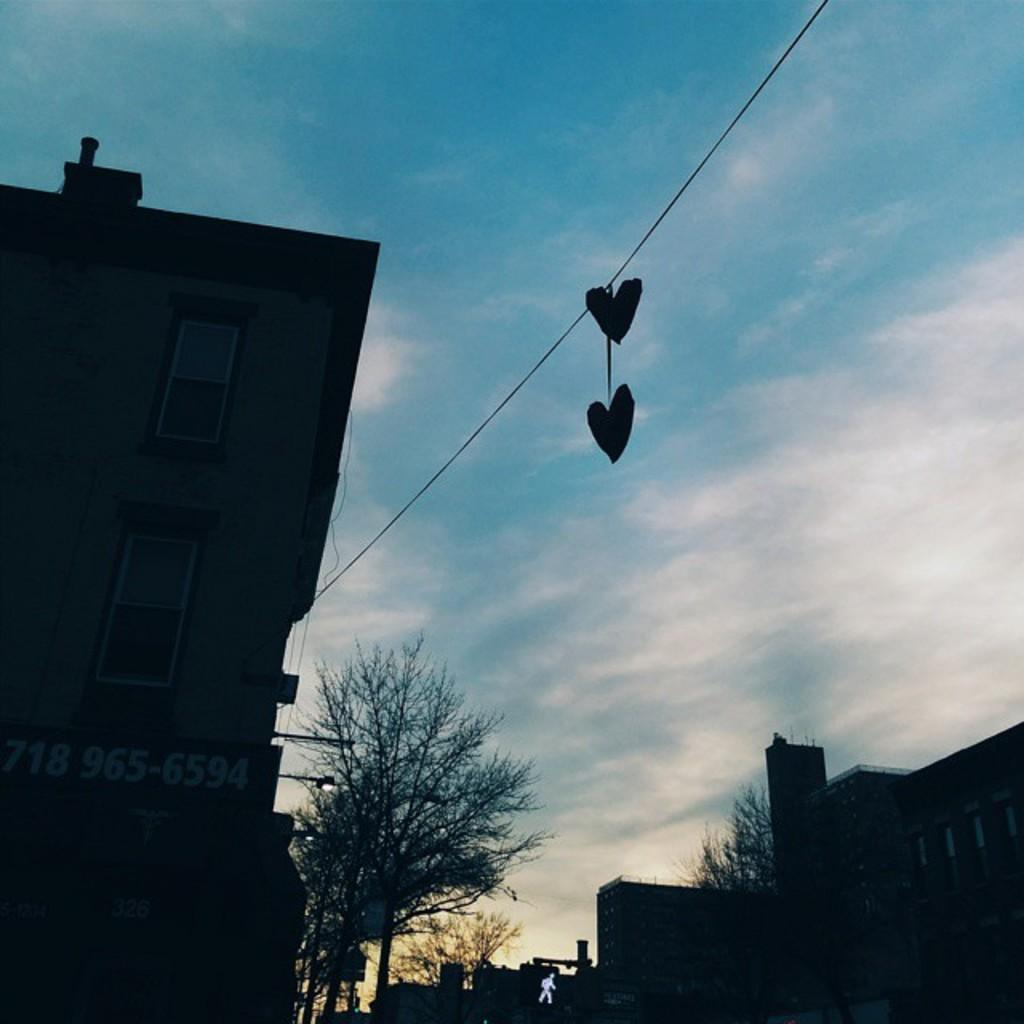What type of structures can be seen in the image? There are buildings in the image. What other natural elements are present in the image? There are trees in the image. Can you describe any man-made objects in the image? There is a board and a sign board in the image. Are there any visible electrical elements in the image? Yes, there are wires in the image. What is visible in the sky at the top of the image? Clouds are present in the sky at the top of the image. Where is the locket hanging in the image? There is no locket present in the image. What type of spot can be seen on the board in the image? There is no spot visible on the board in the image. 